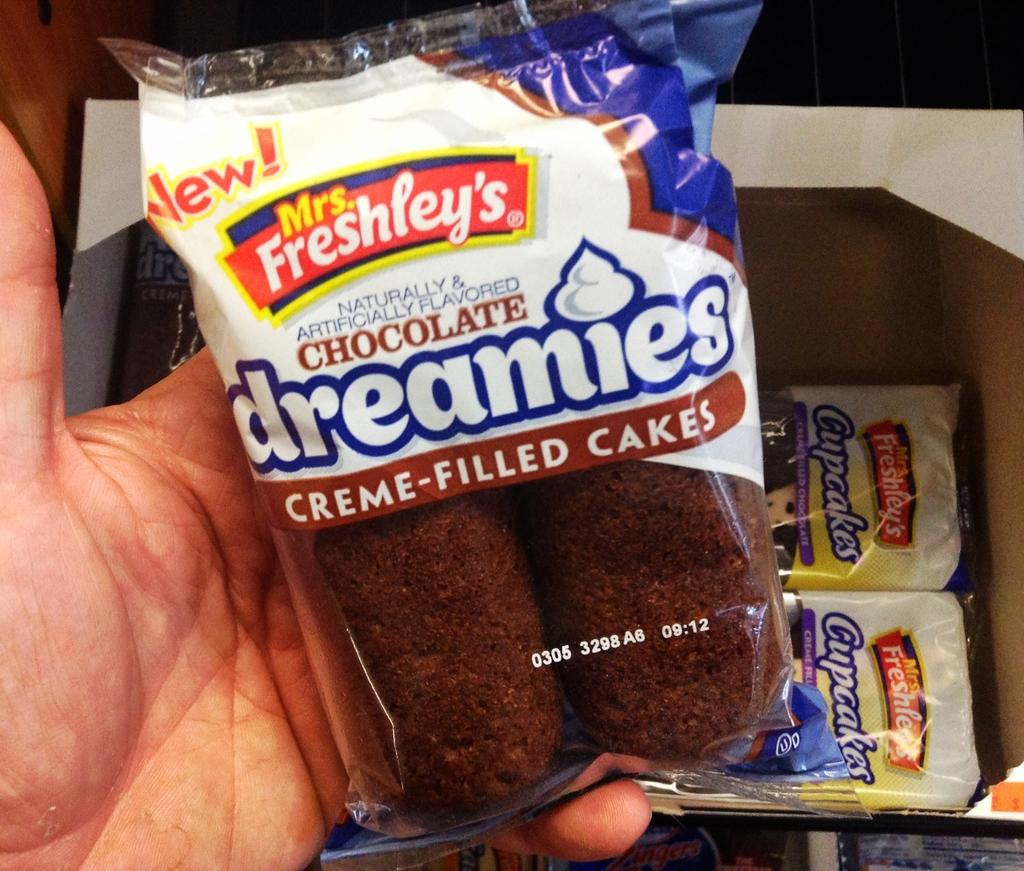<image>
Describe the image concisely. A plastic package holds two Mrs. Freshley's chocolate creme cakes. 